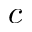<formula> <loc_0><loc_0><loc_500><loc_500>c</formula> 